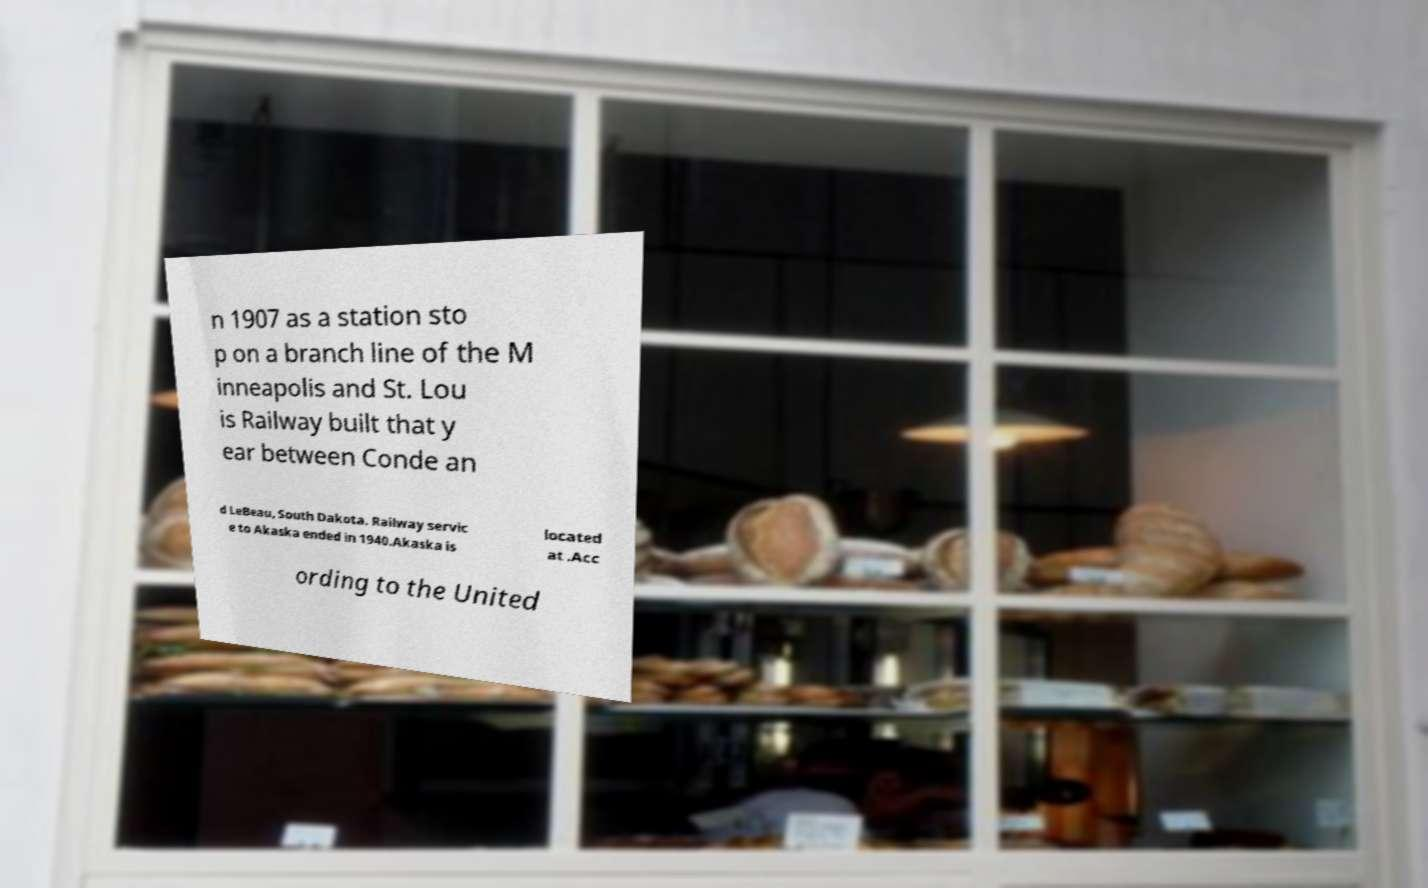Could you assist in decoding the text presented in this image and type it out clearly? n 1907 as a station sto p on a branch line of the M inneapolis and St. Lou is Railway built that y ear between Conde an d LeBeau, South Dakota. Railway servic e to Akaska ended in 1940.Akaska is located at .Acc ording to the United 